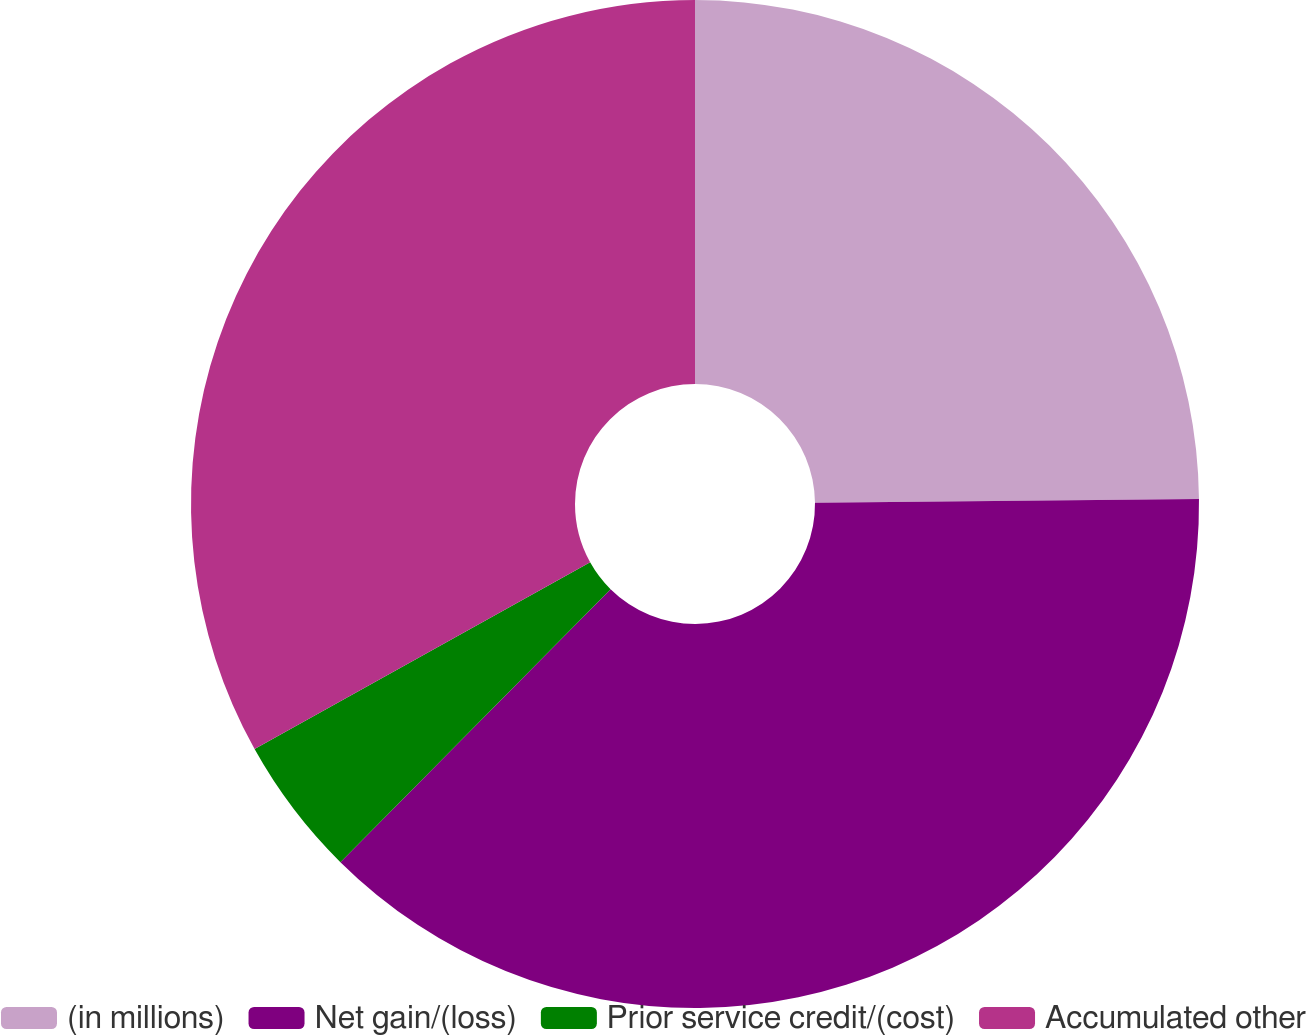Convert chart. <chart><loc_0><loc_0><loc_500><loc_500><pie_chart><fcel>(in millions)<fcel>Net gain/(loss)<fcel>Prior service credit/(cost)<fcel>Accumulated other<nl><fcel>24.84%<fcel>37.58%<fcel>4.5%<fcel>33.08%<nl></chart> 